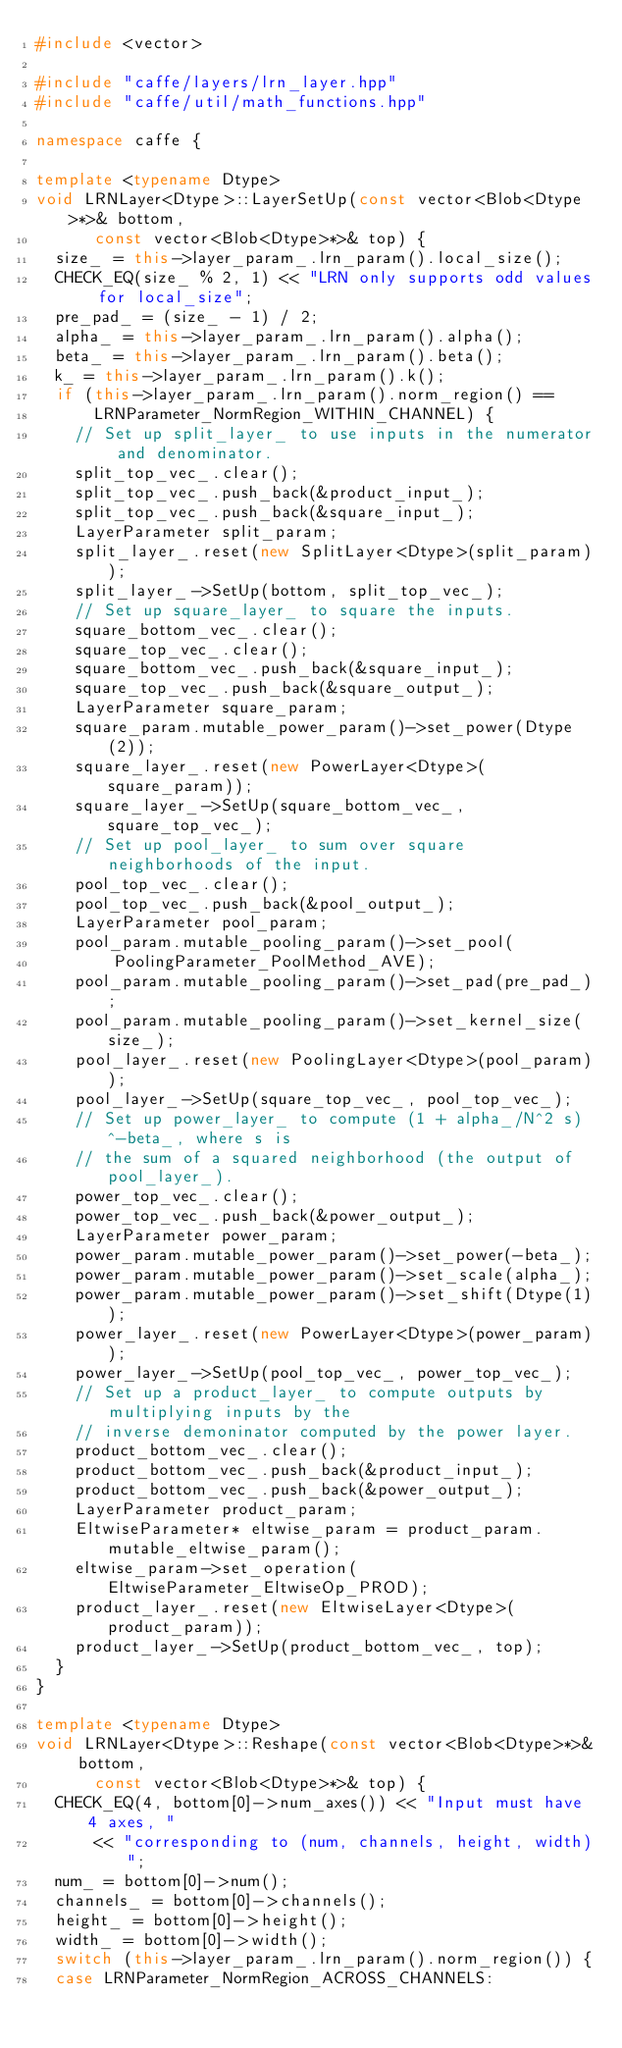Convert code to text. <code><loc_0><loc_0><loc_500><loc_500><_C++_>#include <vector>

#include "caffe/layers/lrn_layer.hpp"
#include "caffe/util/math_functions.hpp"

namespace caffe {

template <typename Dtype>
void LRNLayer<Dtype>::LayerSetUp(const vector<Blob<Dtype>*>& bottom,
      const vector<Blob<Dtype>*>& top) {
  size_ = this->layer_param_.lrn_param().local_size();
  CHECK_EQ(size_ % 2, 1) << "LRN only supports odd values for local_size";
  pre_pad_ = (size_ - 1) / 2;
  alpha_ = this->layer_param_.lrn_param().alpha();
  beta_ = this->layer_param_.lrn_param().beta();
  k_ = this->layer_param_.lrn_param().k();
  if (this->layer_param_.lrn_param().norm_region() ==
      LRNParameter_NormRegion_WITHIN_CHANNEL) {
    // Set up split_layer_ to use inputs in the numerator and denominator.
    split_top_vec_.clear();
    split_top_vec_.push_back(&product_input_);
    split_top_vec_.push_back(&square_input_);
    LayerParameter split_param;
    split_layer_.reset(new SplitLayer<Dtype>(split_param));
    split_layer_->SetUp(bottom, split_top_vec_);
    // Set up square_layer_ to square the inputs.
    square_bottom_vec_.clear();
    square_top_vec_.clear();
    square_bottom_vec_.push_back(&square_input_);
    square_top_vec_.push_back(&square_output_);
    LayerParameter square_param;
    square_param.mutable_power_param()->set_power(Dtype(2));
    square_layer_.reset(new PowerLayer<Dtype>(square_param));
    square_layer_->SetUp(square_bottom_vec_, square_top_vec_);
    // Set up pool_layer_ to sum over square neighborhoods of the input.
    pool_top_vec_.clear();
    pool_top_vec_.push_back(&pool_output_);
    LayerParameter pool_param;
    pool_param.mutable_pooling_param()->set_pool(
        PoolingParameter_PoolMethod_AVE);
    pool_param.mutable_pooling_param()->set_pad(pre_pad_);
    pool_param.mutable_pooling_param()->set_kernel_size(size_);
    pool_layer_.reset(new PoolingLayer<Dtype>(pool_param));
    pool_layer_->SetUp(square_top_vec_, pool_top_vec_);
    // Set up power_layer_ to compute (1 + alpha_/N^2 s)^-beta_, where s is
    // the sum of a squared neighborhood (the output of pool_layer_).
    power_top_vec_.clear();
    power_top_vec_.push_back(&power_output_);
    LayerParameter power_param;
    power_param.mutable_power_param()->set_power(-beta_);
    power_param.mutable_power_param()->set_scale(alpha_);
    power_param.mutable_power_param()->set_shift(Dtype(1));
    power_layer_.reset(new PowerLayer<Dtype>(power_param));
    power_layer_->SetUp(pool_top_vec_, power_top_vec_);
    // Set up a product_layer_ to compute outputs by multiplying inputs by the
    // inverse demoninator computed by the power layer.
    product_bottom_vec_.clear();
    product_bottom_vec_.push_back(&product_input_);
    product_bottom_vec_.push_back(&power_output_);
    LayerParameter product_param;
    EltwiseParameter* eltwise_param = product_param.mutable_eltwise_param();
    eltwise_param->set_operation(EltwiseParameter_EltwiseOp_PROD);
    product_layer_.reset(new EltwiseLayer<Dtype>(product_param));
    product_layer_->SetUp(product_bottom_vec_, top);
  }
}

template <typename Dtype>
void LRNLayer<Dtype>::Reshape(const vector<Blob<Dtype>*>& bottom,
      const vector<Blob<Dtype>*>& top) {
  CHECK_EQ(4, bottom[0]->num_axes()) << "Input must have 4 axes, "
      << "corresponding to (num, channels, height, width)";
  num_ = bottom[0]->num();
  channels_ = bottom[0]->channels();
  height_ = bottom[0]->height();
  width_ = bottom[0]->width();
  switch (this->layer_param_.lrn_param().norm_region()) {
  case LRNParameter_NormRegion_ACROSS_CHANNELS:</code> 